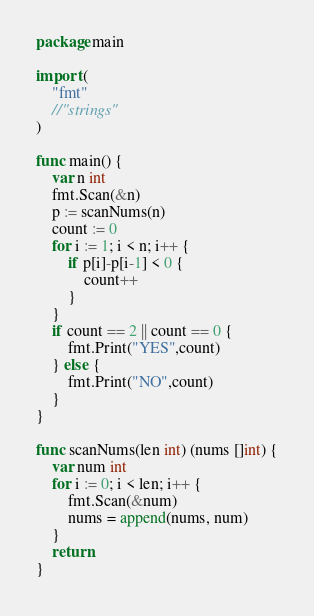Convert code to text. <code><loc_0><loc_0><loc_500><loc_500><_Go_>package main

import (
	"fmt"
	//"strings"
)

func main() {
	var n int
	fmt.Scan(&n)
	p := scanNums(n)
	count := 0
	for i := 1; i < n; i++ {
		if p[i]-p[i-1] < 0 {
			count++
		}
	}
	if count == 2 || count == 0 {
		fmt.Print("YES",count)
	} else {
		fmt.Print("NO",count)
	}
}

func scanNums(len int) (nums []int) {
	var num int
	for i := 0; i < len; i++ {
		fmt.Scan(&num)
		nums = append(nums, num)
	}
	return
}</code> 